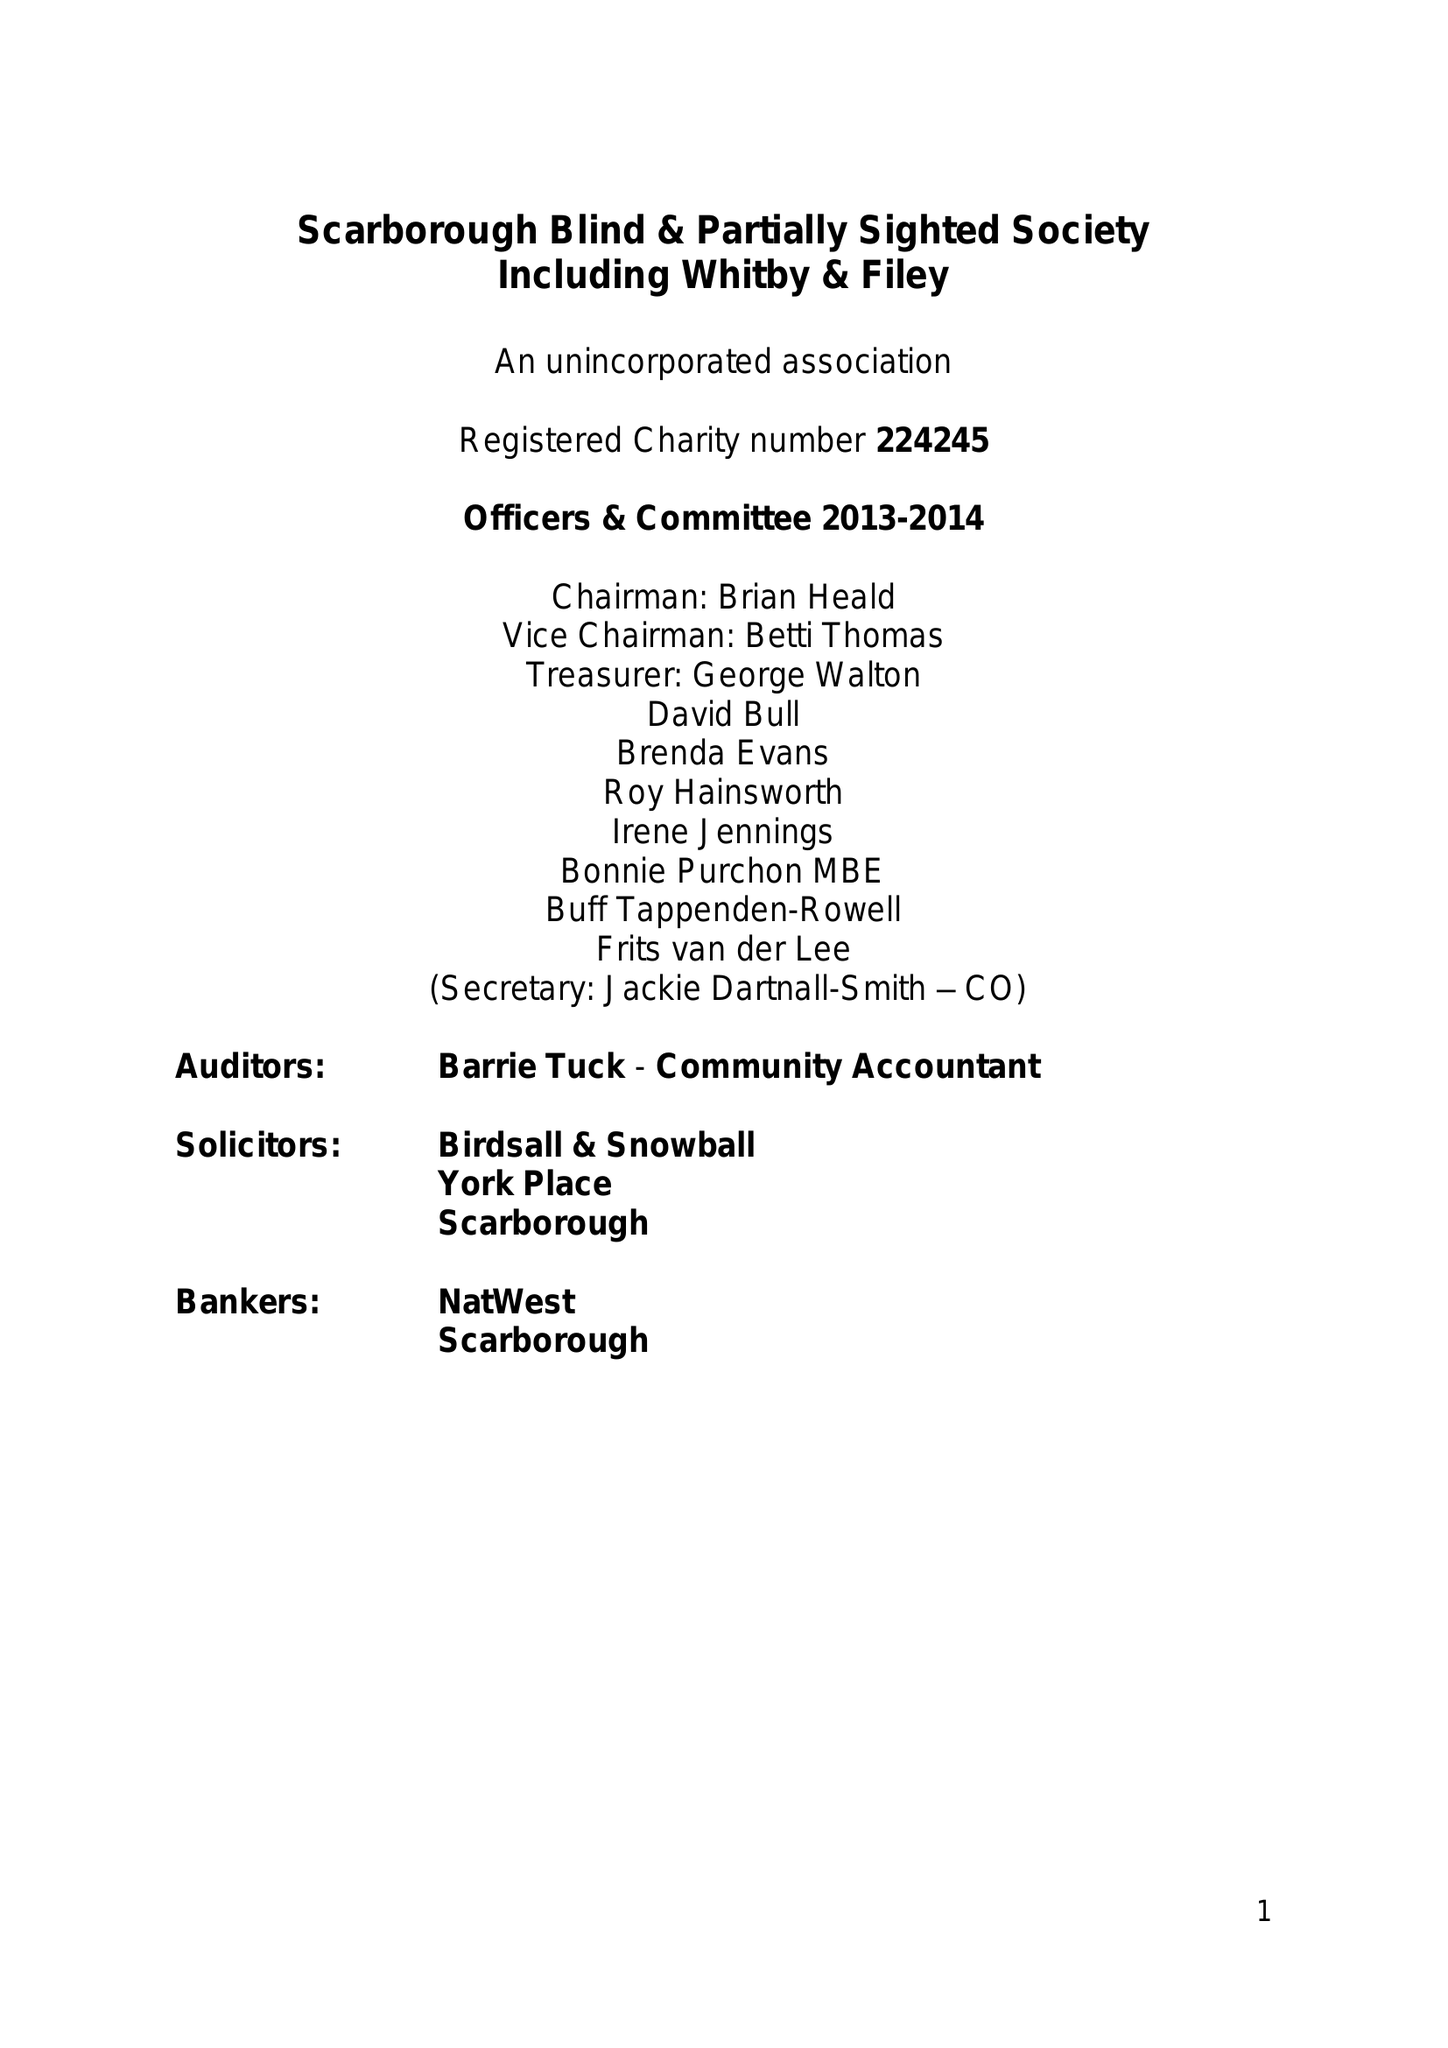What is the value for the address__postcode?
Answer the question using a single word or phrase. YO12 7JH 